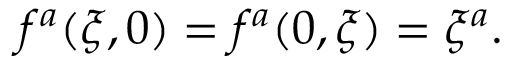Convert formula to latex. <formula><loc_0><loc_0><loc_500><loc_500>f ^ { a } ( \xi , 0 ) = f ^ { a } ( 0 , \xi ) = \xi ^ { a } .</formula> 